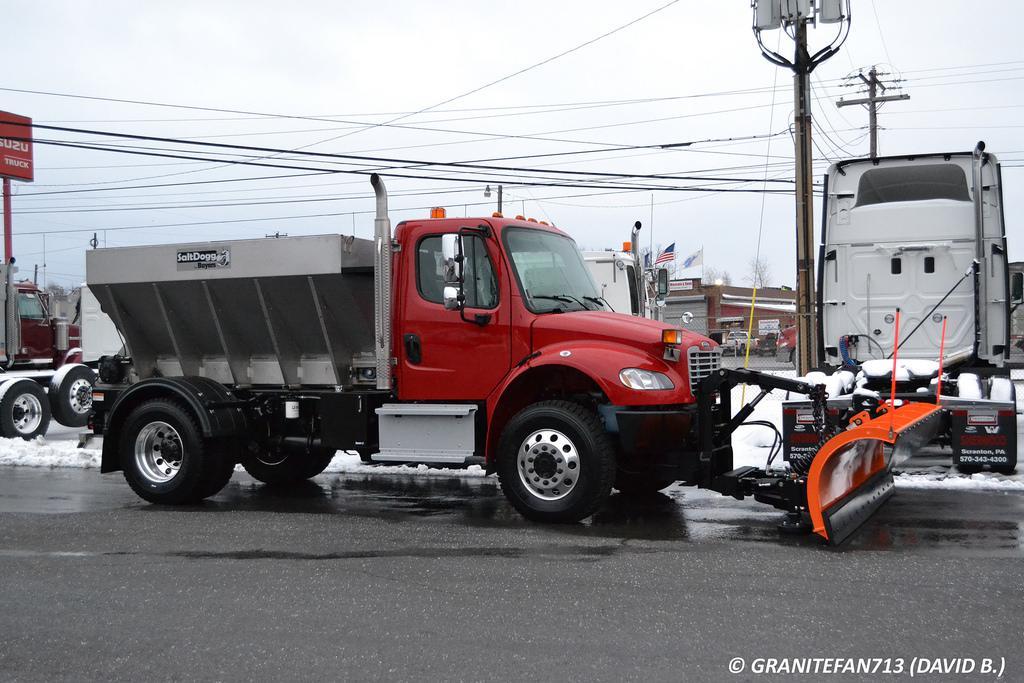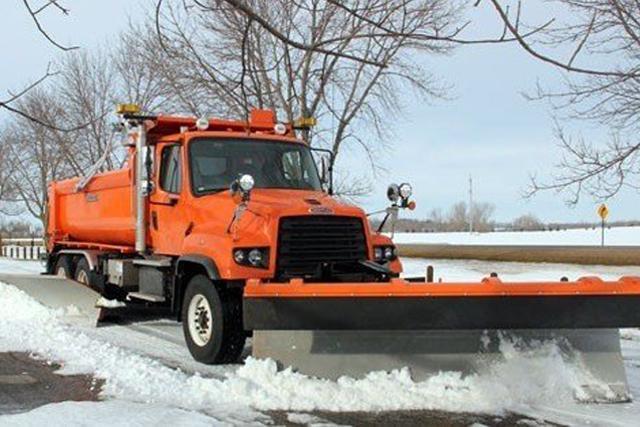The first image is the image on the left, the second image is the image on the right. Considering the images on both sides, is "One snow plow is plowing snow." valid? Answer yes or no. Yes. 